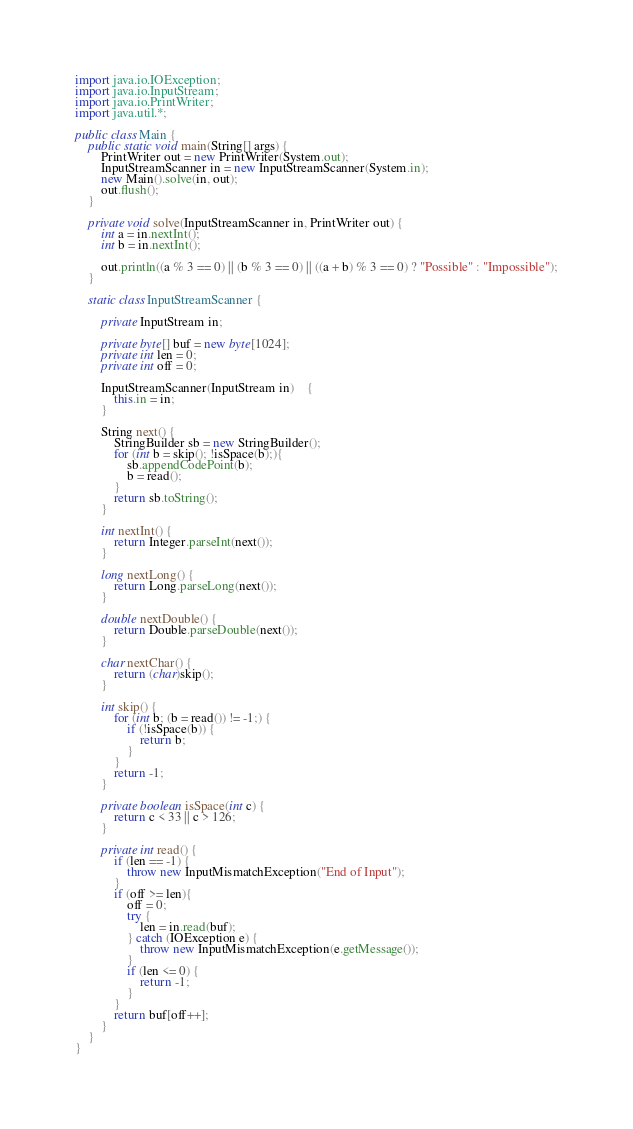<code> <loc_0><loc_0><loc_500><loc_500><_Java_>import java.io.IOException;
import java.io.InputStream;
import java.io.PrintWriter;
import java.util.*;

public class Main {
    public static void main(String[] args) {
        PrintWriter out = new PrintWriter(System.out);
        InputStreamScanner in = new InputStreamScanner(System.in);
        new Main().solve(in, out);
        out.flush();
    }

    private void solve(InputStreamScanner in, PrintWriter out) {
        int a = in.nextInt();
        int b = in.nextInt();

        out.println((a % 3 == 0) || (b % 3 == 0) || ((a + b) % 3 == 0) ? "Possible" : "Impossible");
    }

    static class InputStreamScanner {

        private InputStream in;

        private byte[] buf = new byte[1024];
        private int len = 0;
        private int off = 0;

        InputStreamScanner(InputStream in)	{
            this.in = in;
        }

        String next() {
            StringBuilder sb = new StringBuilder();
            for (int b = skip(); !isSpace(b);){
                sb.appendCodePoint(b);
                b = read();
            }
            return sb.toString();
        }

        int nextInt() {
            return Integer.parseInt(next());
        }

        long nextLong() {
            return Long.parseLong(next());
        }

        double nextDouble() {
            return Double.parseDouble(next());
        }

        char nextChar() {
            return (char)skip();
        }

        int skip() {
            for (int b; (b = read()) != -1;) {
                if (!isSpace(b)) {
                    return b;
                }
            }
            return -1;
        }

        private boolean isSpace(int c) {
            return c < 33 || c > 126;
        }

        private int read() {
            if (len == -1) {
                throw new InputMismatchException("End of Input");
            }
            if (off >= len){
                off = 0;
                try {
                    len = in.read(buf);
                } catch (IOException e) {
                    throw new InputMismatchException(e.getMessage());
                }
                if (len <= 0) {
                    return -1;
                }
            }
            return buf[off++];
        }
    }
}</code> 